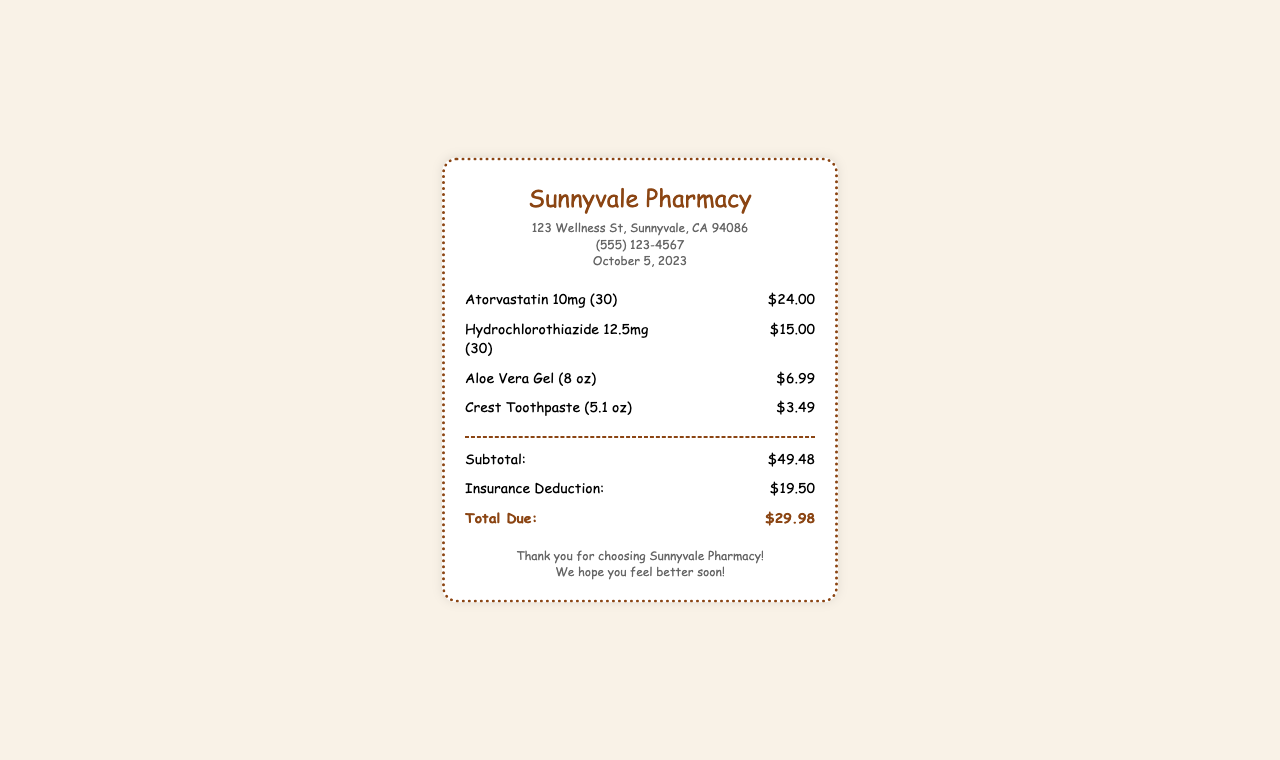What is the name of the pharmacy? The pharmacy's name is listed prominently at the top of the receipt.
Answer: Sunnyvale Pharmacy What is the date of the purchase? The date of the purchase is indicated with the store information.
Answer: October 5, 2023 How much is the Atorvastatin? The price for Atorvastatin is found next to the item description.
Answer: $24.00 What is the subtotal amount? The subtotal is provided in the summary section of the receipt.
Answer: $49.48 What is the insurance deduction amount? The insurance deduction is listed just above the total due.
Answer: $19.50 What is the total amount due? The total amount due is specified in the summary under "Total Due".
Answer: $29.98 How many items were purchased? The number of items can be counted from the list of items on the receipt.
Answer: 4 What is the address of the pharmacy? The address is included in the store information section.
Answer: 123 Wellness St, Sunnyvale, CA 94086 What types of products were purchased? The receipt lists both medications and hygiene products.
Answer: Medications and hygiene products 